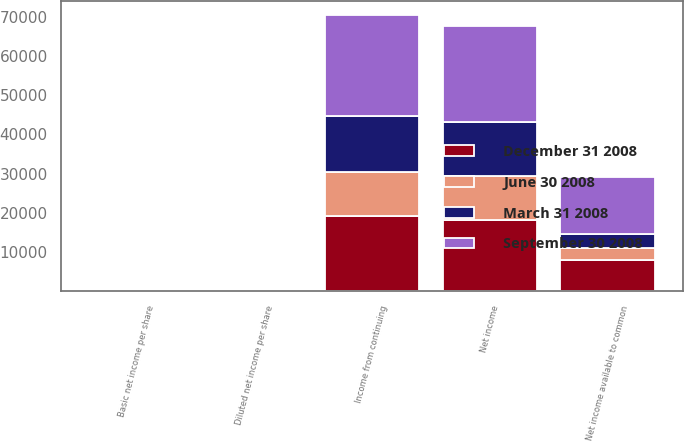Convert chart to OTSL. <chart><loc_0><loc_0><loc_500><loc_500><stacked_bar_chart><ecel><fcel>Income from continuing<fcel>Net income<fcel>Net income available to common<fcel>Basic net income per share<fcel>Diluted net income per share<nl><fcel>September 30 2008<fcel>25830<fcel>24538<fcel>14436<fcel>0.2<fcel>0.2<nl><fcel>December 31 2008<fcel>19069<fcel>18185<fcel>8083<fcel>0.11<fcel>0.11<nl><fcel>March 31 2008<fcel>14246<fcel>13830<fcel>3728<fcel>0.06<fcel>0.05<nl><fcel>June 30 2008<fcel>11402<fcel>11108<fcel>2850<fcel>0.04<fcel>0.04<nl></chart> 